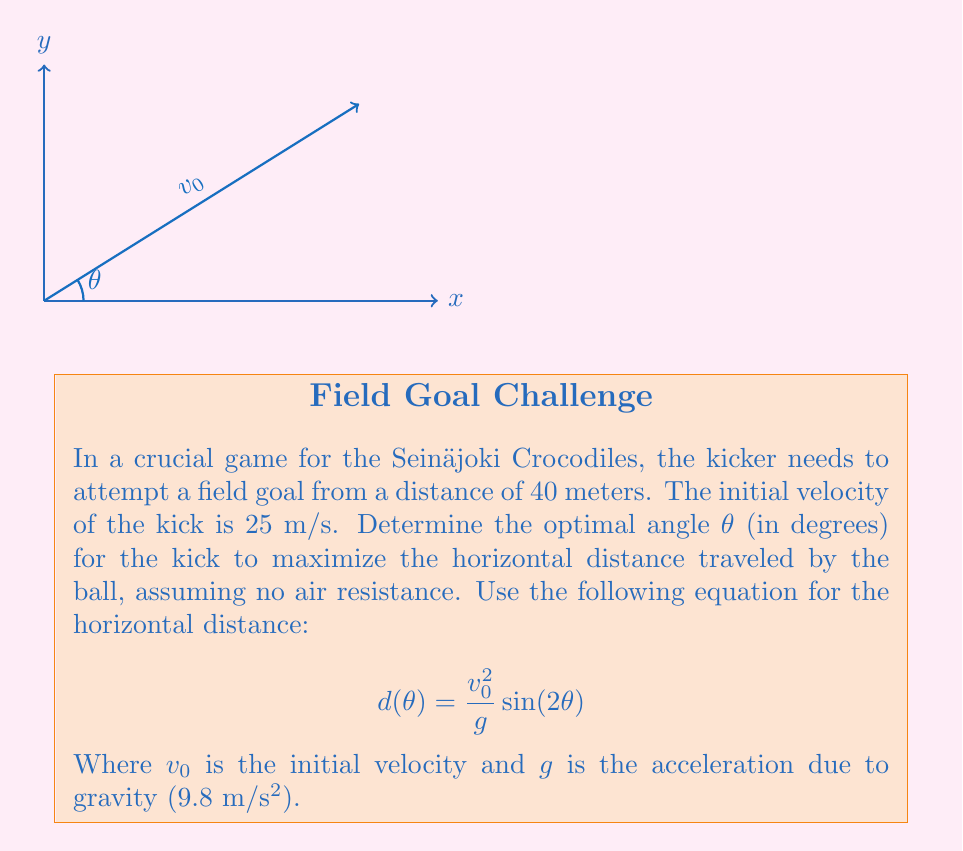Can you solve this math problem? To find the optimal angle, we need to maximize the function $d(θ)$. We can do this by finding where its derivative equals zero:

1) First, let's take the derivative of $d(θ)$ with respect to θ:

   $$d'(θ) = \frac{v_0^2}{g} \cdot 2\cos(2θ)$$

2) Set this equal to zero and solve for θ:

   $$\frac{v_0^2}{g} \cdot 2\cos(2θ) = 0$$
   $$\cos(2θ) = 0$$

3) The cosine function equals zero when its argument is $\frac{π}{2}$ or $\frac{3π}{2}$. So:

   $$2θ = \frac{π}{2}$$ or $$2θ = \frac{3π}{2}$$

4) Solving for θ:

   $$θ = \frac{π}{4}$$ or $$θ = \frac{3π}{4}$$

5) The angle $\frac{π}{4}$ (45°) gives us the maximum, while $\frac{3π}{4}$ (135°) gives us the minimum.

6) Convert $\frac{π}{4}$ radians to degrees:

   $$\frac{π}{4} \cdot \frac{180°}{π} = 45°$$

Therefore, the optimal angle for the kick is 45°.
Answer: 45° 